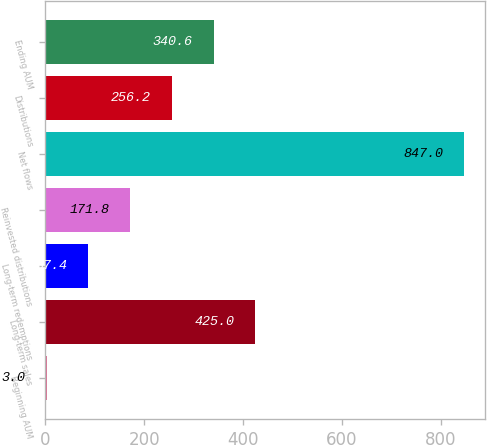Convert chart. <chart><loc_0><loc_0><loc_500><loc_500><bar_chart><fcel>Beginning AUM<fcel>Long-term sales<fcel>Long-term redemptions<fcel>Reinvested distributions<fcel>Net flows<fcel>Distributions<fcel>Ending AUM<nl><fcel>3<fcel>425<fcel>87.4<fcel>171.8<fcel>847<fcel>256.2<fcel>340.6<nl></chart> 